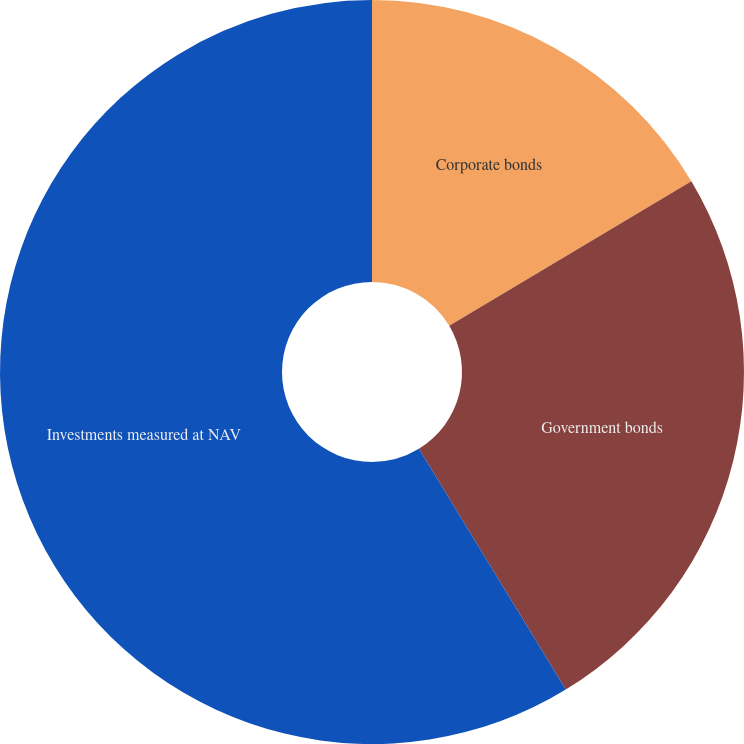<chart> <loc_0><loc_0><loc_500><loc_500><pie_chart><fcel>Corporate bonds<fcel>Government bonds<fcel>Investments measured at NAV<nl><fcel>16.43%<fcel>24.85%<fcel>58.72%<nl></chart> 